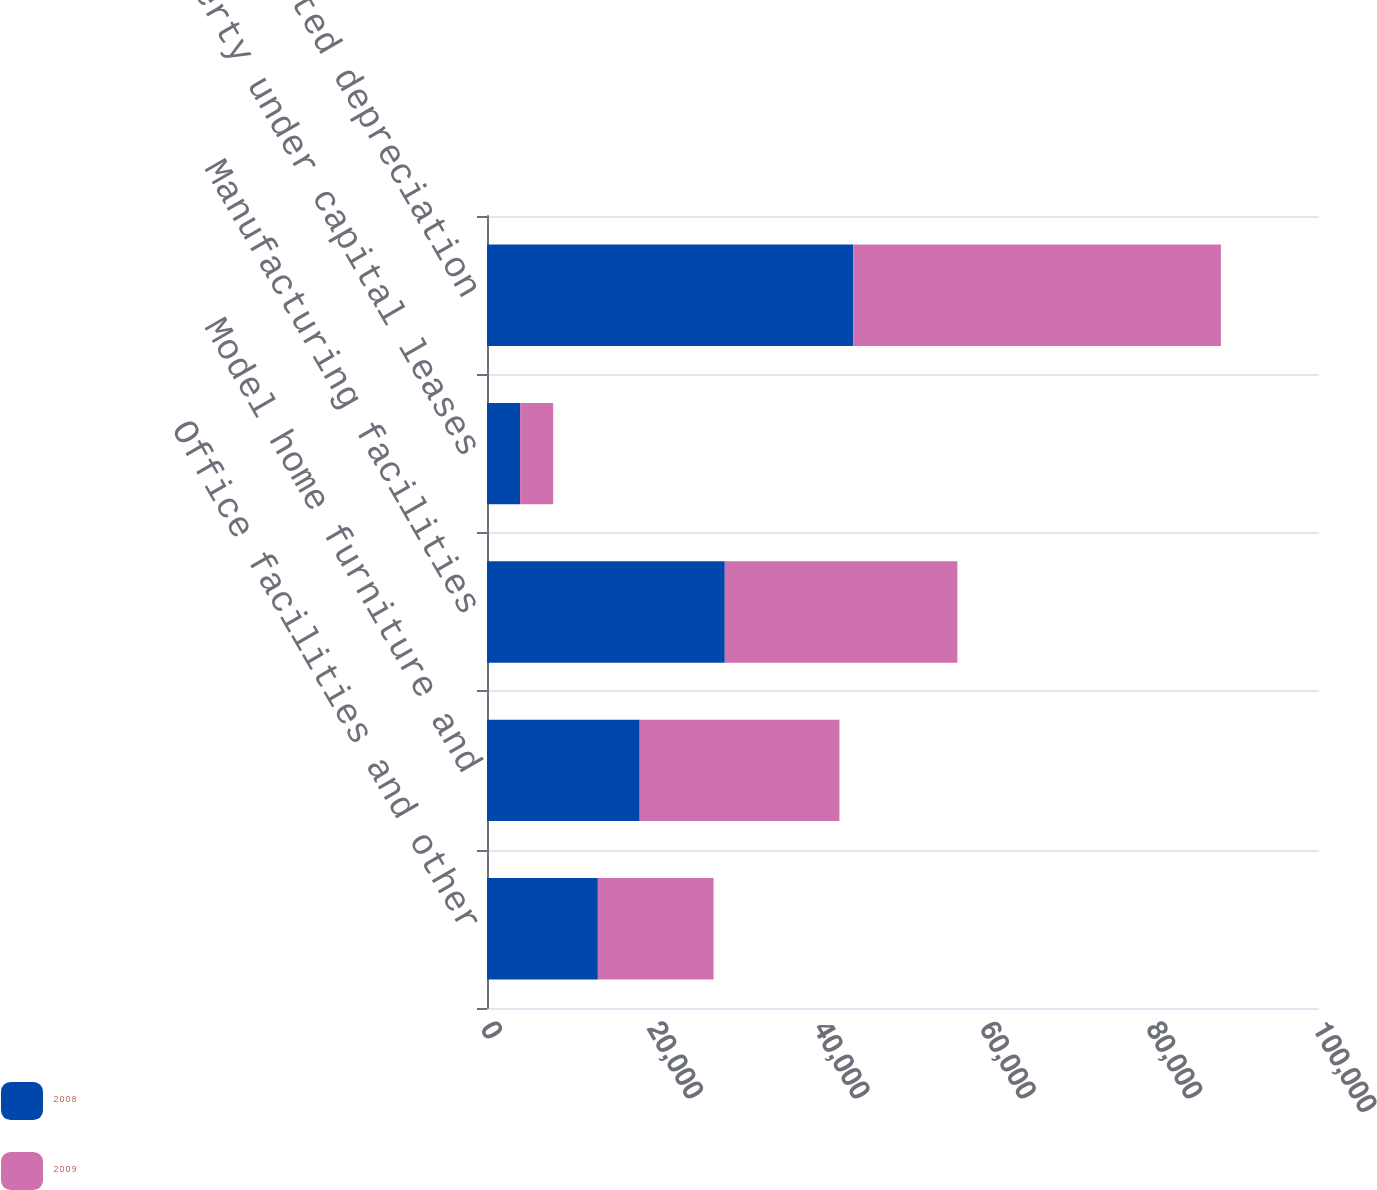Convert chart to OTSL. <chart><loc_0><loc_0><loc_500><loc_500><stacked_bar_chart><ecel><fcel>Office facilities and other<fcel>Model home furniture and<fcel>Manufacturing facilities<fcel>Property under capital leases<fcel>Less accumulated depreciation<nl><fcel>2008<fcel>13324<fcel>18354<fcel>28581<fcel>3976<fcel>44020<nl><fcel>2009<fcel>13908<fcel>24003<fcel>27957<fcel>3976<fcel>44186<nl></chart> 